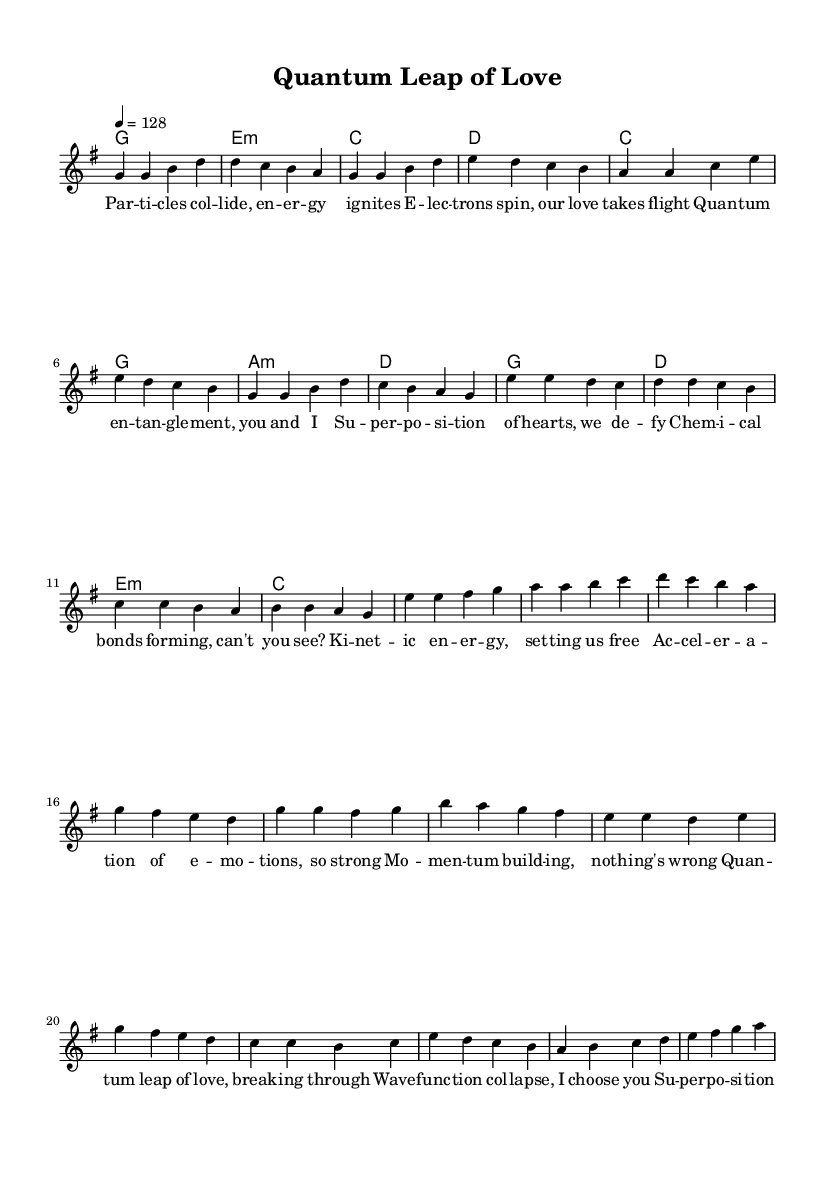What is the key signature of this music? The key signature is G major, which contains one sharp (F#). This can be determined by looking at the key signature notation at the beginning of the score.
Answer: G major What is the time signature of this piece? The time signature is 4/4, indicated at the beginning of the score. This means there are four beats per measure, and the quarter note gets one beat.
Answer: 4/4 What is the tempo marked for this music? The tempo is marked at 128 beats per minute, as indicated by "4 = 128." This shows how fast the music should be played.
Answer: 128 What chord follows the first verse? The chord following the first verse is E minor, which can be found by examining the harmony line directly below the melody of the verse.
Answer: E minor How many measures are there in the pre-chorus? The pre-chorus consists of four measures, as counted from the staff section labeled with the notes and corresponding lyrics. Each line of lyrics corresponds to one measure, and there are four lines.
Answer: 4 What scientific concept is repeated in the chorus lyrics? The chorus lyrics repeat the concept "quantum," which can be identified by reviewing the lyrics section of the chorus for any repeated terminology.
Answer: Quantum How does the use of scientific terms enhance the theme of the song? The use of scientific terms like "quantum entanglement" and "superposition" conveys a creative analogy to love and relationships, suggesting a deeper connection that transcends ordinary experiences. This enhances the theme by likening emotional bonds to scientific phenomena, evoking a sense of excitement and complexity.
Answer: Enhances theme 